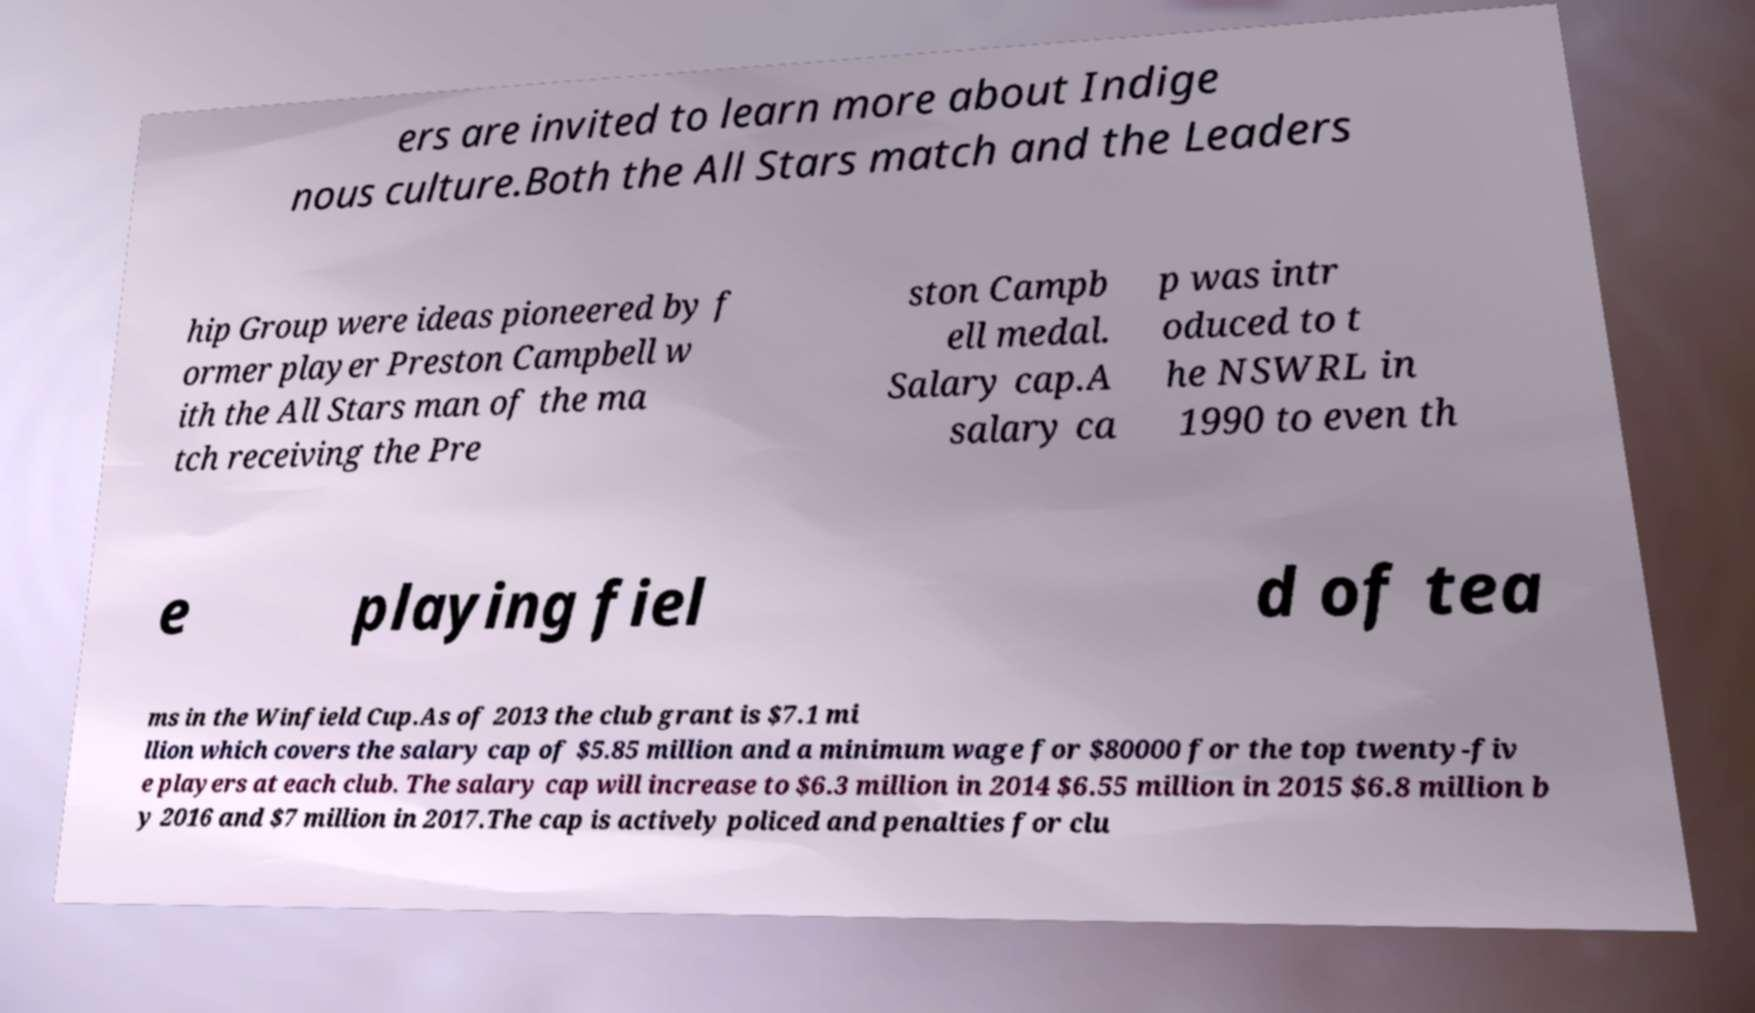For documentation purposes, I need the text within this image transcribed. Could you provide that? ers are invited to learn more about Indige nous culture.Both the All Stars match and the Leaders hip Group were ideas pioneered by f ormer player Preston Campbell w ith the All Stars man of the ma tch receiving the Pre ston Campb ell medal. Salary cap.A salary ca p was intr oduced to t he NSWRL in 1990 to even th e playing fiel d of tea ms in the Winfield Cup.As of 2013 the club grant is $7.1 mi llion which covers the salary cap of $5.85 million and a minimum wage for $80000 for the top twenty-fiv e players at each club. The salary cap will increase to $6.3 million in 2014 $6.55 million in 2015 $6.8 million b y 2016 and $7 million in 2017.The cap is actively policed and penalties for clu 